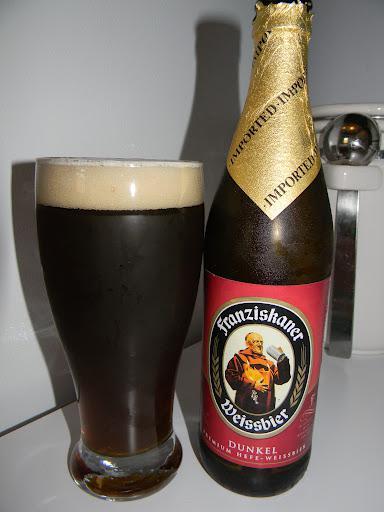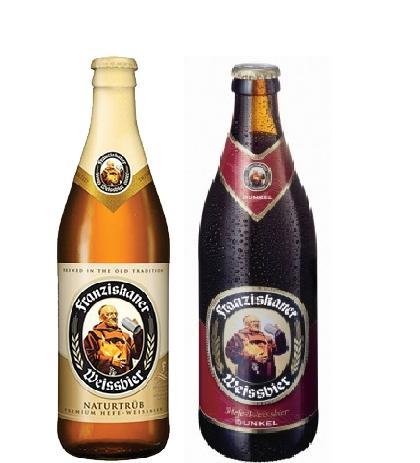The first image is the image on the left, the second image is the image on the right. For the images displayed, is the sentence "In one image, a glass of ale is sitting next to a bottle of ale." factually correct? Answer yes or no. Yes. The first image is the image on the left, the second image is the image on the right. Considering the images on both sides, is "The left image contains both a bottle and a glass." valid? Answer yes or no. Yes. 